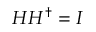Convert formula to latex. <formula><loc_0><loc_0><loc_500><loc_500>H H ^ { \dagger } = I</formula> 